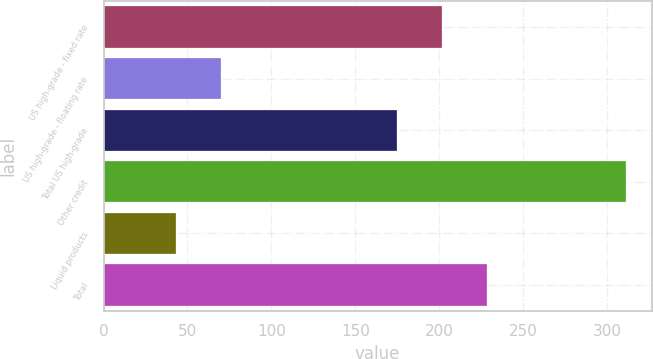Convert chart to OTSL. <chart><loc_0><loc_0><loc_500><loc_500><bar_chart><fcel>US high-grade - fixed rate<fcel>US high-grade - floating rate<fcel>Total US high-grade<fcel>Other credit<fcel>Liquid products<fcel>Total<nl><fcel>201.8<fcel>69.8<fcel>175<fcel>311<fcel>43<fcel>228.6<nl></chart> 